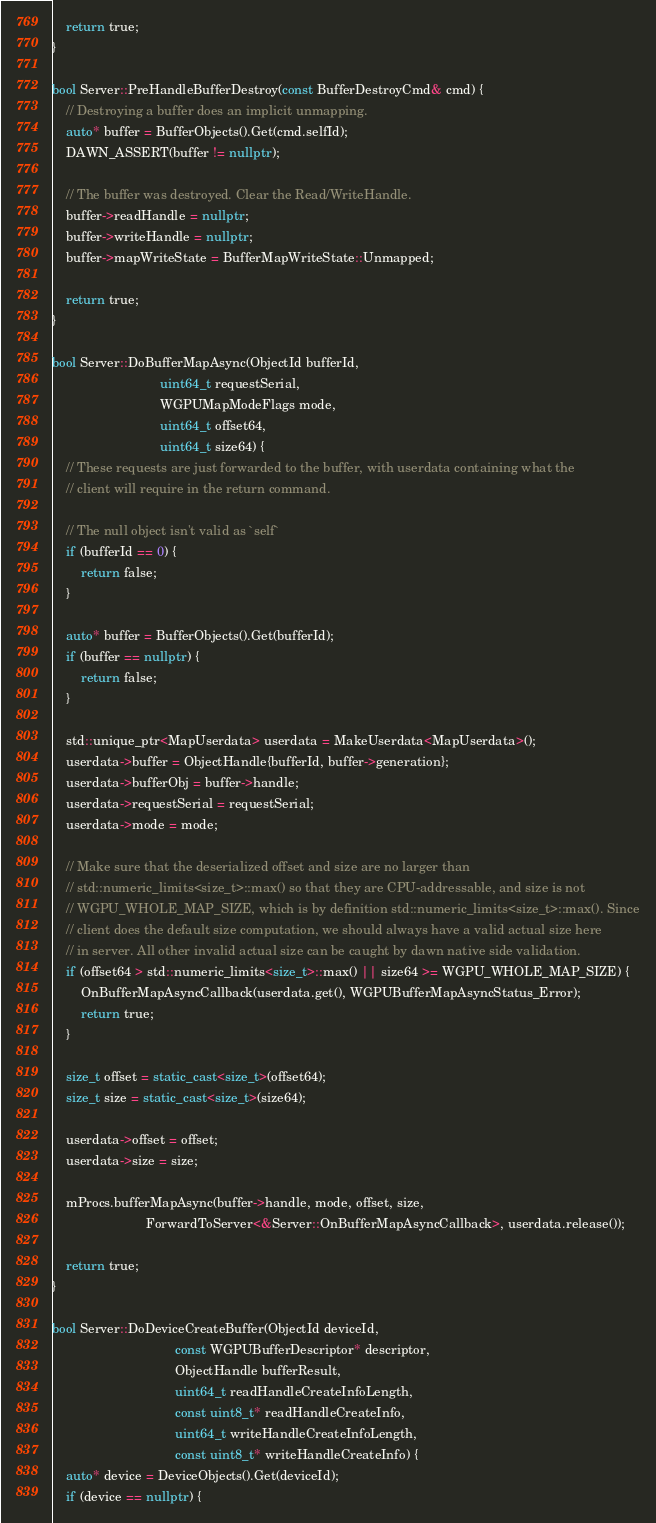<code> <loc_0><loc_0><loc_500><loc_500><_C++_>    return true;
}

bool Server::PreHandleBufferDestroy(const BufferDestroyCmd& cmd) {
    // Destroying a buffer does an implicit unmapping.
    auto* buffer = BufferObjects().Get(cmd.selfId);
    DAWN_ASSERT(buffer != nullptr);

    // The buffer was destroyed. Clear the Read/WriteHandle.
    buffer->readHandle = nullptr;
    buffer->writeHandle = nullptr;
    buffer->mapWriteState = BufferMapWriteState::Unmapped;

    return true;
}

bool Server::DoBufferMapAsync(ObjectId bufferId,
                              uint64_t requestSerial,
                              WGPUMapModeFlags mode,
                              uint64_t offset64,
                              uint64_t size64) {
    // These requests are just forwarded to the buffer, with userdata containing what the
    // client will require in the return command.

    // The null object isn't valid as `self`
    if (bufferId == 0) {
        return false;
    }

    auto* buffer = BufferObjects().Get(bufferId);
    if (buffer == nullptr) {
        return false;
    }

    std::unique_ptr<MapUserdata> userdata = MakeUserdata<MapUserdata>();
    userdata->buffer = ObjectHandle{bufferId, buffer->generation};
    userdata->bufferObj = buffer->handle;
    userdata->requestSerial = requestSerial;
    userdata->mode = mode;

    // Make sure that the deserialized offset and size are no larger than
    // std::numeric_limits<size_t>::max() so that they are CPU-addressable, and size is not
    // WGPU_WHOLE_MAP_SIZE, which is by definition std::numeric_limits<size_t>::max(). Since
    // client does the default size computation, we should always have a valid actual size here
    // in server. All other invalid actual size can be caught by dawn native side validation.
    if (offset64 > std::numeric_limits<size_t>::max() || size64 >= WGPU_WHOLE_MAP_SIZE) {
        OnBufferMapAsyncCallback(userdata.get(), WGPUBufferMapAsyncStatus_Error);
        return true;
    }

    size_t offset = static_cast<size_t>(offset64);
    size_t size = static_cast<size_t>(size64);

    userdata->offset = offset;
    userdata->size = size;

    mProcs.bufferMapAsync(buffer->handle, mode, offset, size,
                          ForwardToServer<&Server::OnBufferMapAsyncCallback>, userdata.release());

    return true;
}

bool Server::DoDeviceCreateBuffer(ObjectId deviceId,
                                  const WGPUBufferDescriptor* descriptor,
                                  ObjectHandle bufferResult,
                                  uint64_t readHandleCreateInfoLength,
                                  const uint8_t* readHandleCreateInfo,
                                  uint64_t writeHandleCreateInfoLength,
                                  const uint8_t* writeHandleCreateInfo) {
    auto* device = DeviceObjects().Get(deviceId);
    if (device == nullptr) {</code> 